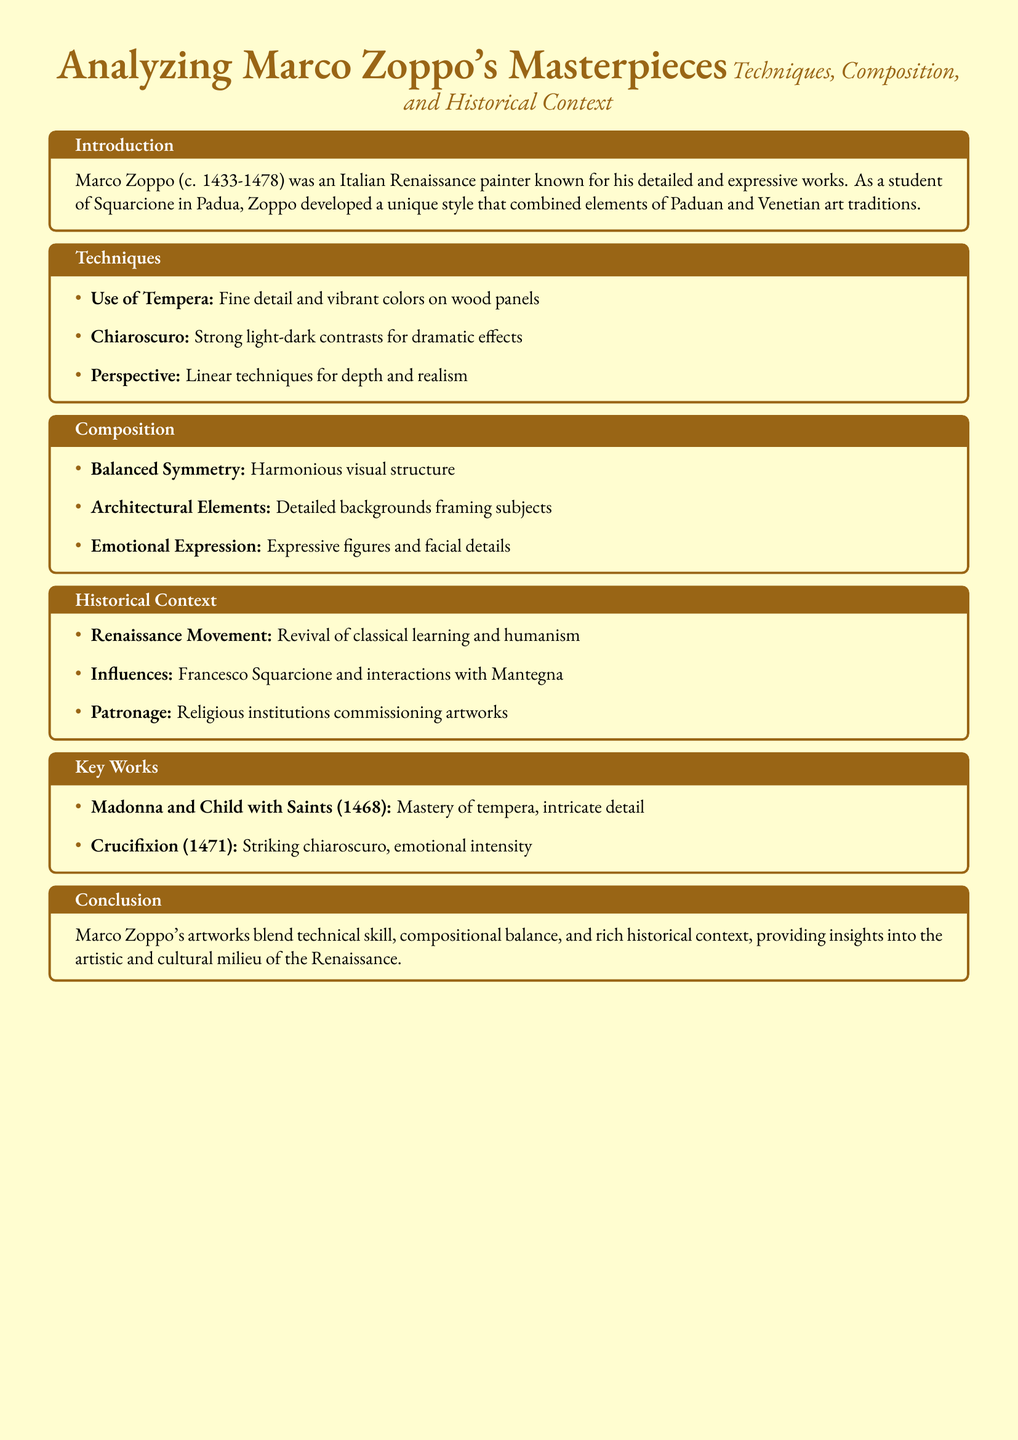What year was Marco Zoppo born? The document states that Marco Zoppo was born around 1433.
Answer: 1433 What technique did Zoppo use for his paintings? According to the document, Zoppo primarily used tempera for his fine detail and vibrant colors.
Answer: Tempera Which painting showcases Zoppo's mastery of tempera? The guide mentions "Madonna and Child with Saints (1468)" as a key work demonstrating this mastery.
Answer: Madonna and Child with Saints What compositional feature is highlighted in Zoppo's works? The document states that Zoppo's compositions often exhibit balanced symmetry.
Answer: Balanced Symmetry Who were Zoppo's influential figures? The document notes Francesco Squarcione and Mantegna as key influences on Zoppo's work.
Answer: Squarcione and Mantegna In which historical movement did Marco Zoppo operate? The guide indicates that Zoppo was a part of the Renaissance movement.
Answer: Renaissance What year was the painting "Crucifixion" completed? The document mentions that the "Crucifixion" was completed in 1471.
Answer: 1471 What kind of patronage did Zoppo receive? The historical context section states that religious institutions were significant patrons of Zoppo's artworks.
Answer: Religious institutions What was Zoppo's primary art medium? The document explains that Zoppo primarily used tempera for his artworks.
Answer: Tempera 